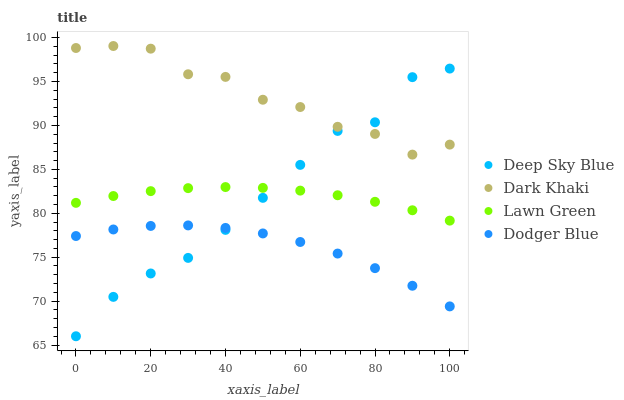Does Dodger Blue have the minimum area under the curve?
Answer yes or no. Yes. Does Dark Khaki have the maximum area under the curve?
Answer yes or no. Yes. Does Lawn Green have the minimum area under the curve?
Answer yes or no. No. Does Lawn Green have the maximum area under the curve?
Answer yes or no. No. Is Lawn Green the smoothest?
Answer yes or no. Yes. Is Dark Khaki the roughest?
Answer yes or no. Yes. Is Dodger Blue the smoothest?
Answer yes or no. No. Is Dodger Blue the roughest?
Answer yes or no. No. Does Deep Sky Blue have the lowest value?
Answer yes or no. Yes. Does Lawn Green have the lowest value?
Answer yes or no. No. Does Dark Khaki have the highest value?
Answer yes or no. Yes. Does Lawn Green have the highest value?
Answer yes or no. No. Is Dodger Blue less than Dark Khaki?
Answer yes or no. Yes. Is Dark Khaki greater than Dodger Blue?
Answer yes or no. Yes. Does Dodger Blue intersect Deep Sky Blue?
Answer yes or no. Yes. Is Dodger Blue less than Deep Sky Blue?
Answer yes or no. No. Is Dodger Blue greater than Deep Sky Blue?
Answer yes or no. No. Does Dodger Blue intersect Dark Khaki?
Answer yes or no. No. 